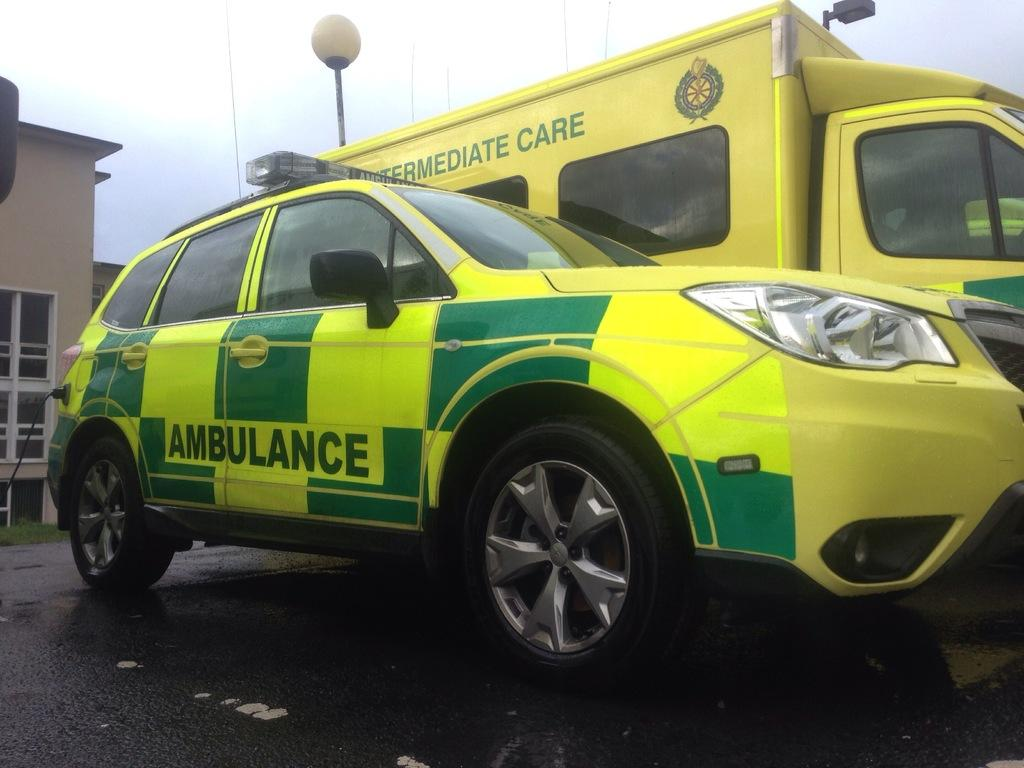<image>
Give a short and clear explanation of the subsequent image. an ambulance that is next to a bigger car 